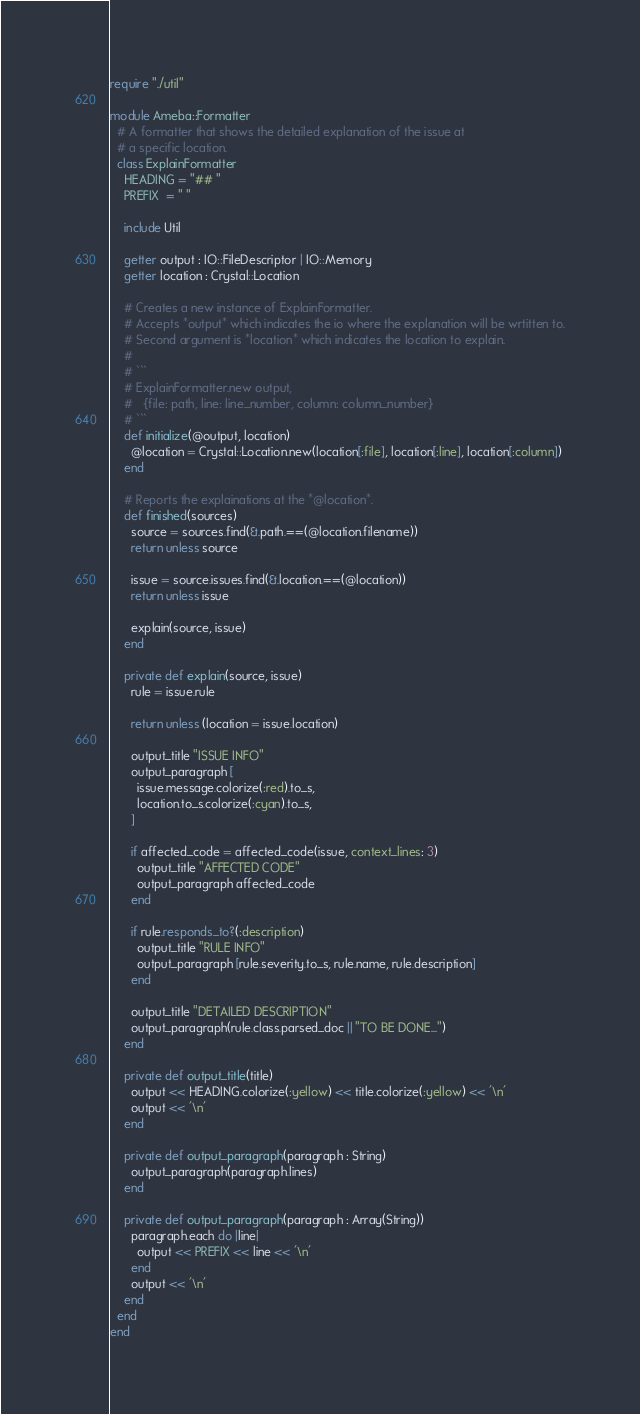Convert code to text. <code><loc_0><loc_0><loc_500><loc_500><_Crystal_>require "./util"

module Ameba::Formatter
  # A formatter that shows the detailed explanation of the issue at
  # a specific location.
  class ExplainFormatter
    HEADING = "## "
    PREFIX  = " "

    include Util

    getter output : IO::FileDescriptor | IO::Memory
    getter location : Crystal::Location

    # Creates a new instance of ExplainFormatter.
    # Accepts *output* which indicates the io where the explanation will be wrtitten to.
    # Second argument is *location* which indicates the location to explain.
    #
    # ```
    # ExplainFormatter.new output,
    #   {file: path, line: line_number, column: column_number}
    # ```
    def initialize(@output, location)
      @location = Crystal::Location.new(location[:file], location[:line], location[:column])
    end

    # Reports the explainations at the *@location*.
    def finished(sources)
      source = sources.find(&.path.==(@location.filename))
      return unless source

      issue = source.issues.find(&.location.==(@location))
      return unless issue

      explain(source, issue)
    end

    private def explain(source, issue)
      rule = issue.rule

      return unless (location = issue.location)

      output_title "ISSUE INFO"
      output_paragraph [
        issue.message.colorize(:red).to_s,
        location.to_s.colorize(:cyan).to_s,
      ]

      if affected_code = affected_code(issue, context_lines: 3)
        output_title "AFFECTED CODE"
        output_paragraph affected_code
      end

      if rule.responds_to?(:description)
        output_title "RULE INFO"
        output_paragraph [rule.severity.to_s, rule.name, rule.description]
      end

      output_title "DETAILED DESCRIPTION"
      output_paragraph(rule.class.parsed_doc || "TO BE DONE...")
    end

    private def output_title(title)
      output << HEADING.colorize(:yellow) << title.colorize(:yellow) << '\n'
      output << '\n'
    end

    private def output_paragraph(paragraph : String)
      output_paragraph(paragraph.lines)
    end

    private def output_paragraph(paragraph : Array(String))
      paragraph.each do |line|
        output << PREFIX << line << '\n'
      end
      output << '\n'
    end
  end
end
</code> 